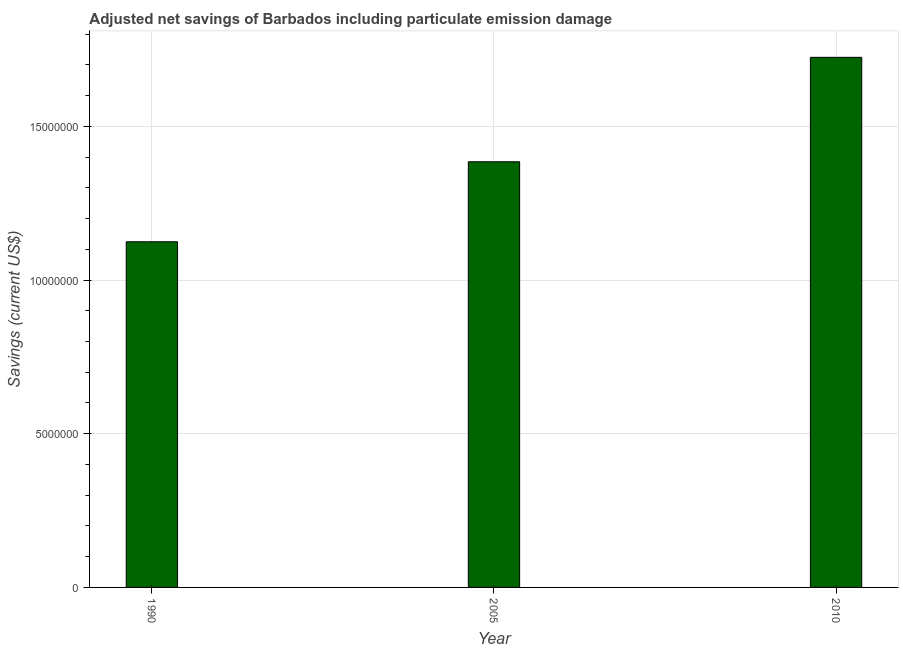Does the graph contain any zero values?
Ensure brevity in your answer.  No. What is the title of the graph?
Provide a short and direct response. Adjusted net savings of Barbados including particulate emission damage. What is the label or title of the X-axis?
Give a very brief answer. Year. What is the label or title of the Y-axis?
Make the answer very short. Savings (current US$). What is the adjusted net savings in 1990?
Give a very brief answer. 1.12e+07. Across all years, what is the maximum adjusted net savings?
Give a very brief answer. 1.72e+07. Across all years, what is the minimum adjusted net savings?
Offer a terse response. 1.12e+07. In which year was the adjusted net savings maximum?
Keep it short and to the point. 2010. In which year was the adjusted net savings minimum?
Offer a very short reply. 1990. What is the sum of the adjusted net savings?
Your answer should be compact. 4.23e+07. What is the difference between the adjusted net savings in 2005 and 2010?
Give a very brief answer. -3.40e+06. What is the average adjusted net savings per year?
Your response must be concise. 1.41e+07. What is the median adjusted net savings?
Your answer should be compact. 1.38e+07. What is the ratio of the adjusted net savings in 2005 to that in 2010?
Give a very brief answer. 0.8. Is the adjusted net savings in 1990 less than that in 2010?
Your response must be concise. Yes. What is the difference between the highest and the second highest adjusted net savings?
Your answer should be compact. 3.40e+06. What is the difference between the highest and the lowest adjusted net savings?
Give a very brief answer. 6.00e+06. In how many years, is the adjusted net savings greater than the average adjusted net savings taken over all years?
Your answer should be very brief. 1. How many bars are there?
Your answer should be very brief. 3. Are all the bars in the graph horizontal?
Make the answer very short. No. How many years are there in the graph?
Your answer should be very brief. 3. What is the Savings (current US$) in 1990?
Offer a very short reply. 1.12e+07. What is the Savings (current US$) in 2005?
Offer a very short reply. 1.38e+07. What is the Savings (current US$) in 2010?
Offer a very short reply. 1.72e+07. What is the difference between the Savings (current US$) in 1990 and 2005?
Your answer should be compact. -2.60e+06. What is the difference between the Savings (current US$) in 1990 and 2010?
Your answer should be compact. -6.00e+06. What is the difference between the Savings (current US$) in 2005 and 2010?
Offer a terse response. -3.40e+06. What is the ratio of the Savings (current US$) in 1990 to that in 2005?
Your answer should be very brief. 0.81. What is the ratio of the Savings (current US$) in 1990 to that in 2010?
Your response must be concise. 0.65. What is the ratio of the Savings (current US$) in 2005 to that in 2010?
Your answer should be compact. 0.8. 